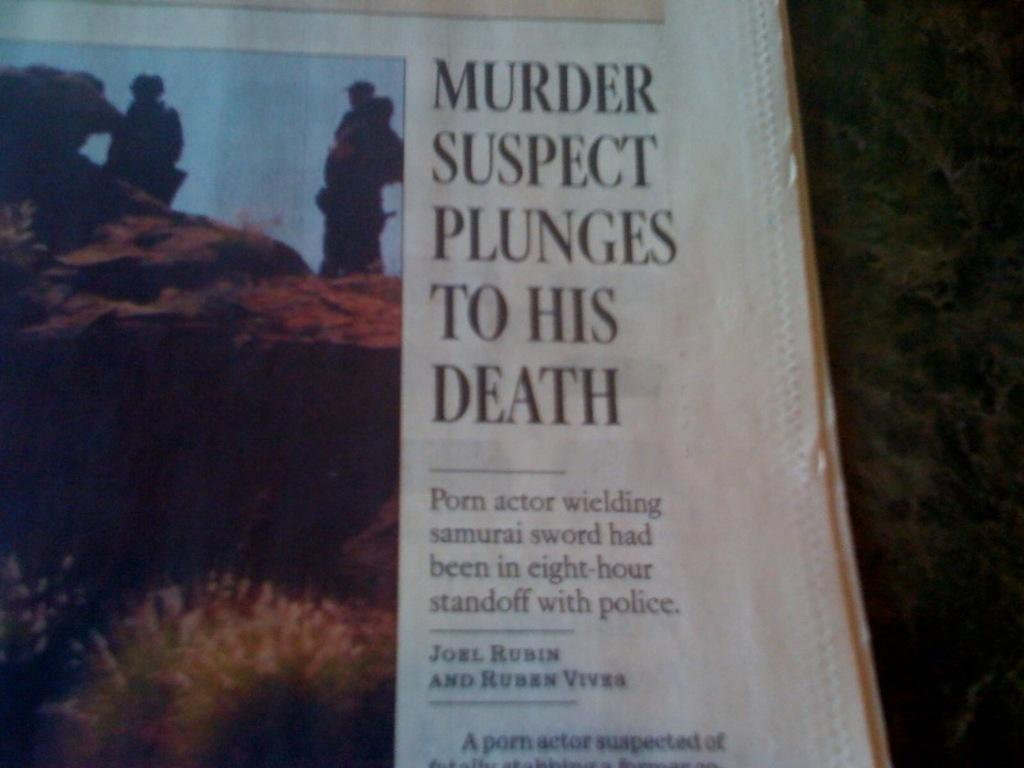<image>
Present a compact description of the photo's key features. A newspaper shows an image next to a headline about a murder suspect. 